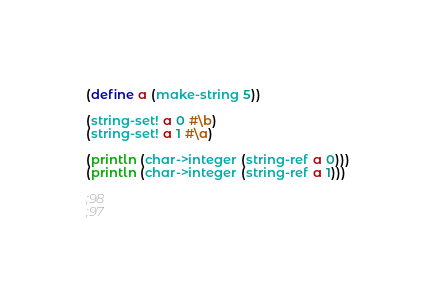<code> <loc_0><loc_0><loc_500><loc_500><_Scheme_>(define a (make-string 5))

(string-set! a 0 #\b)
(string-set! a 1 #\a)

(println (char->integer (string-ref a 0)))
(println (char->integer (string-ref a 1)))

;98
;97
</code> 